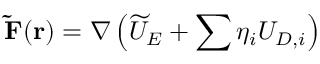<formula> <loc_0><loc_0><loc_500><loc_500>\widetilde { F } ( \mathbf { r } ) = \nabla \left ( \widetilde { U } _ { E } + \sum \eta _ { i } U _ { D , i } \right )</formula> 